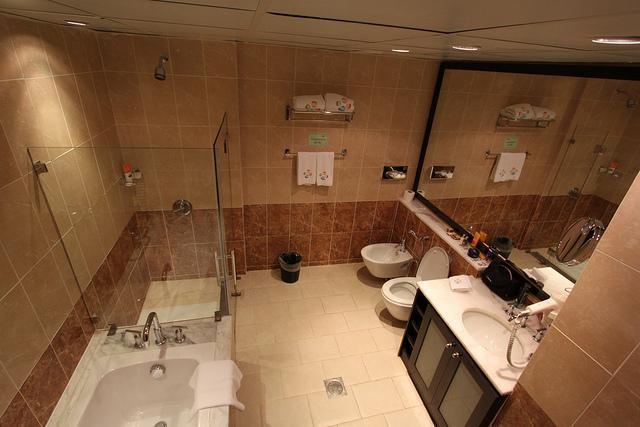How many towels are there by the toilet?
Give a very brief answer. 2. How many sinks are there?
Give a very brief answer. 2. How many people are wearing helmets?
Give a very brief answer. 0. 